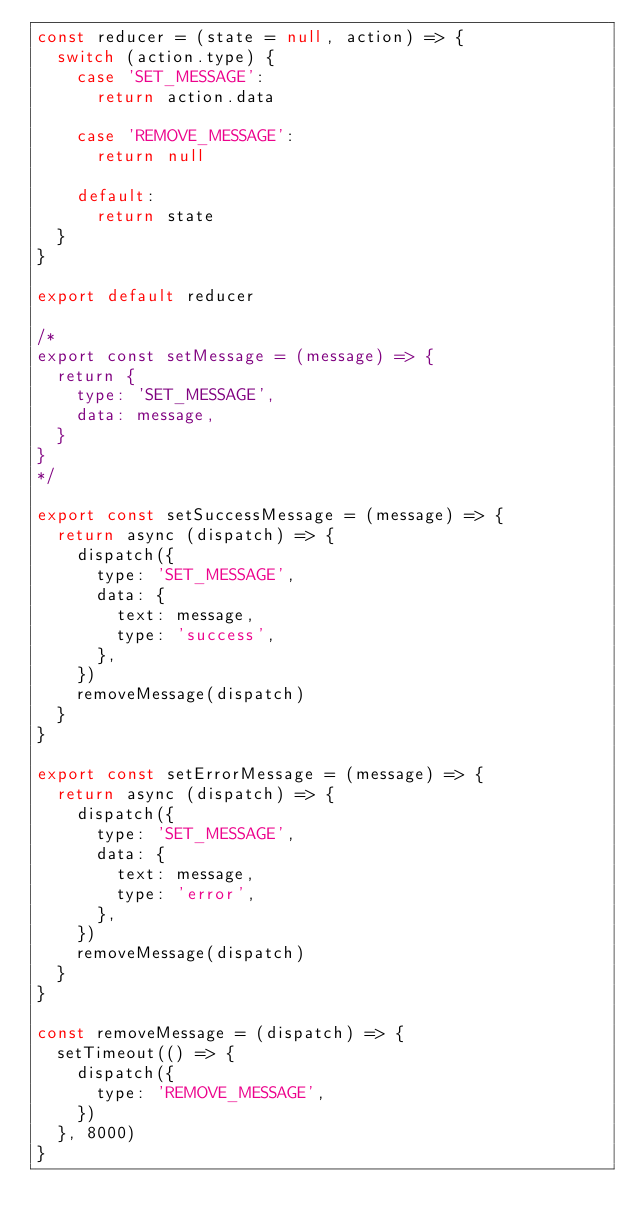Convert code to text. <code><loc_0><loc_0><loc_500><loc_500><_JavaScript_>const reducer = (state = null, action) => {
  switch (action.type) {
    case 'SET_MESSAGE':
      return action.data

    case 'REMOVE_MESSAGE':
      return null

    default:
      return state
  }
}

export default reducer

/*
export const setMessage = (message) => {
  return {
    type: 'SET_MESSAGE',
    data: message,
  }
}
*/

export const setSuccessMessage = (message) => {
  return async (dispatch) => {
    dispatch({
      type: 'SET_MESSAGE',
      data: {
        text: message,
        type: 'success',
      },
    })
    removeMessage(dispatch)
  }
}

export const setErrorMessage = (message) => {
  return async (dispatch) => {
    dispatch({
      type: 'SET_MESSAGE',
      data: {
        text: message,
        type: 'error',
      },
    })
    removeMessage(dispatch)
  }
}

const removeMessage = (dispatch) => {
  setTimeout(() => {
    dispatch({
      type: 'REMOVE_MESSAGE',
    })
  }, 8000)
}
</code> 